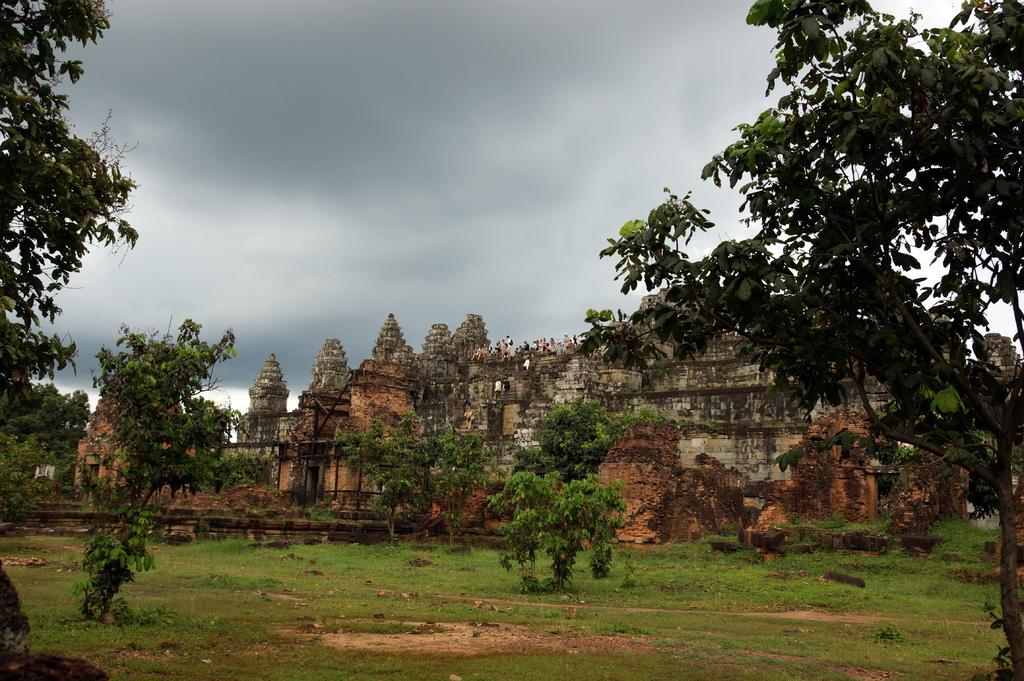What type of vegetation is present in the image? There are trees and grass in the image. What structures can be seen in the image? There are buildings in the middle of the image. What is visible in the background of the image? The sky is visible in the background of the image. How would you describe the sky in the image? The sky appears to be cloudy in the image. Where are the babies playing in the image? There are no babies present in the image. What season is depicted in the image? The provided facts do not mention a specific season, so it cannot be determined from the image. 